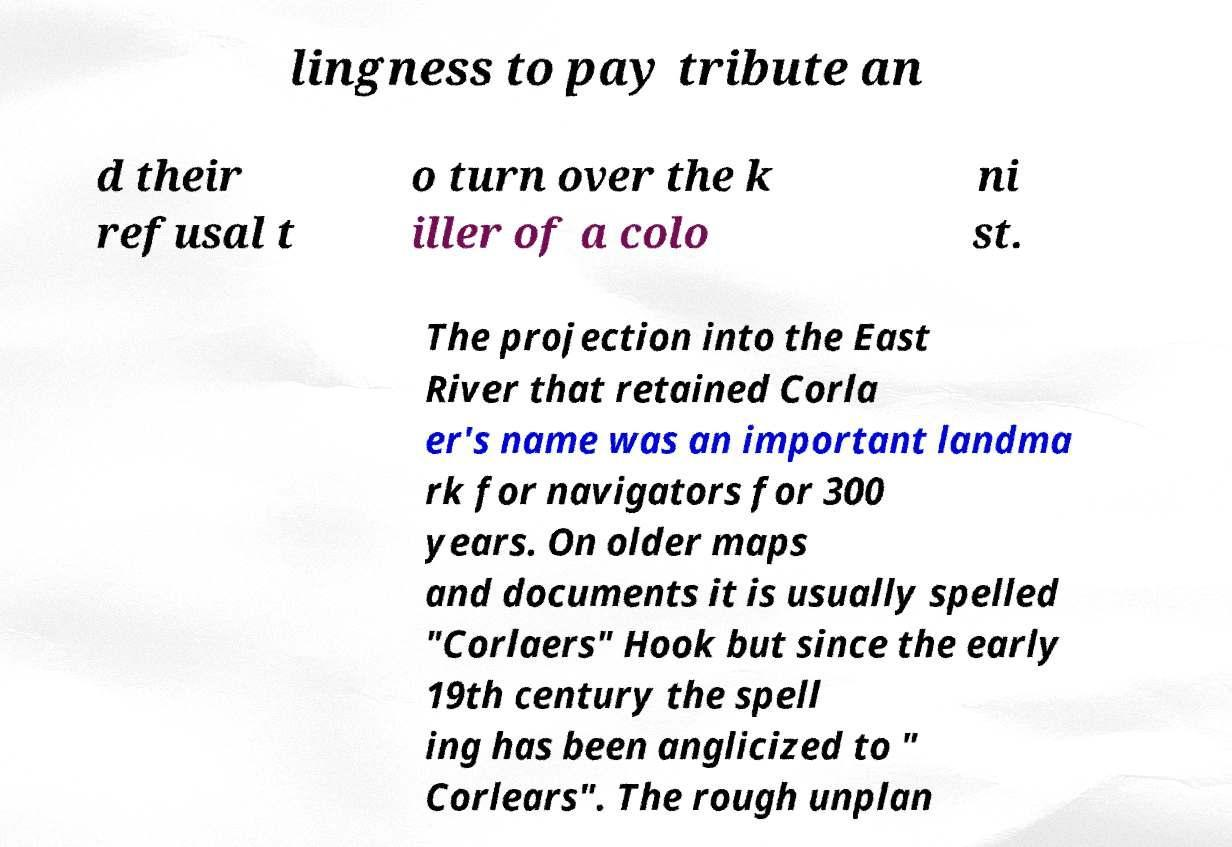For documentation purposes, I need the text within this image transcribed. Could you provide that? lingness to pay tribute an d their refusal t o turn over the k iller of a colo ni st. The projection into the East River that retained Corla er's name was an important landma rk for navigators for 300 years. On older maps and documents it is usually spelled "Corlaers" Hook but since the early 19th century the spell ing has been anglicized to " Corlears". The rough unplan 